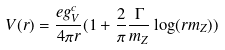<formula> <loc_0><loc_0><loc_500><loc_500>V ( r ) = \frac { e g _ { V } ^ { c } } { 4 \pi r } ( 1 + \frac { 2 } { \pi } \frac { \Gamma } { m _ { Z } } \log ( r m _ { Z } ) )</formula> 